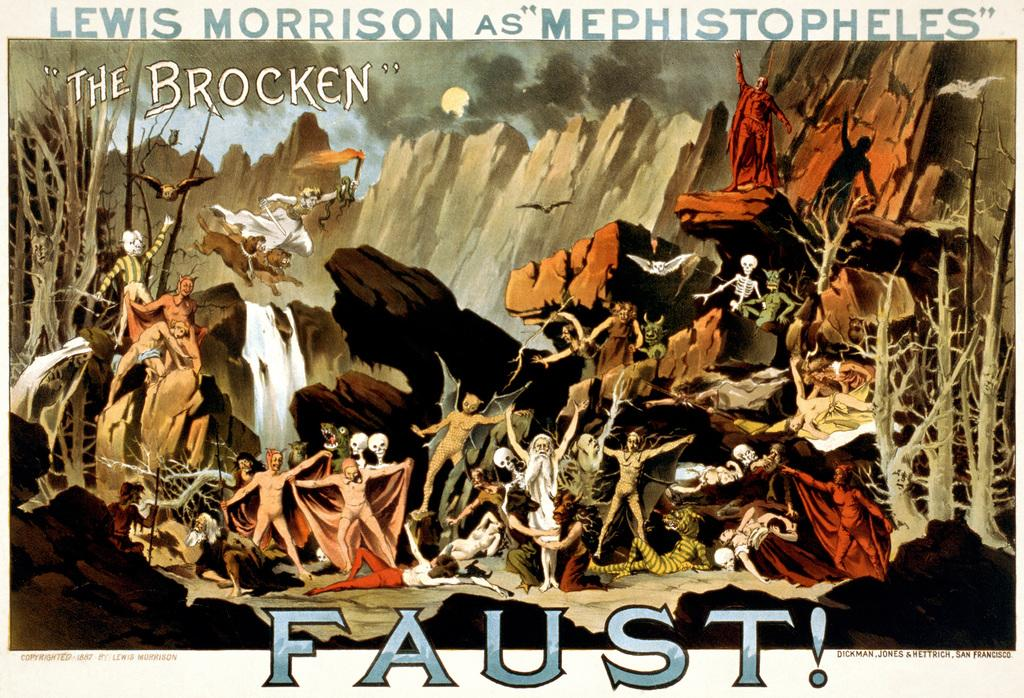What type of image is being described? The image is an animated painting. Can you describe the main subject in the image? There is a person in the image. What other objects are present around the person? There are skulls around the person. Are there any text elements in the image? Yes, there are letters in the image. How many ducks are swimming in the water near the person in the image? There are no ducks present in the image; it features a person surrounded by skulls in an animated painting. 